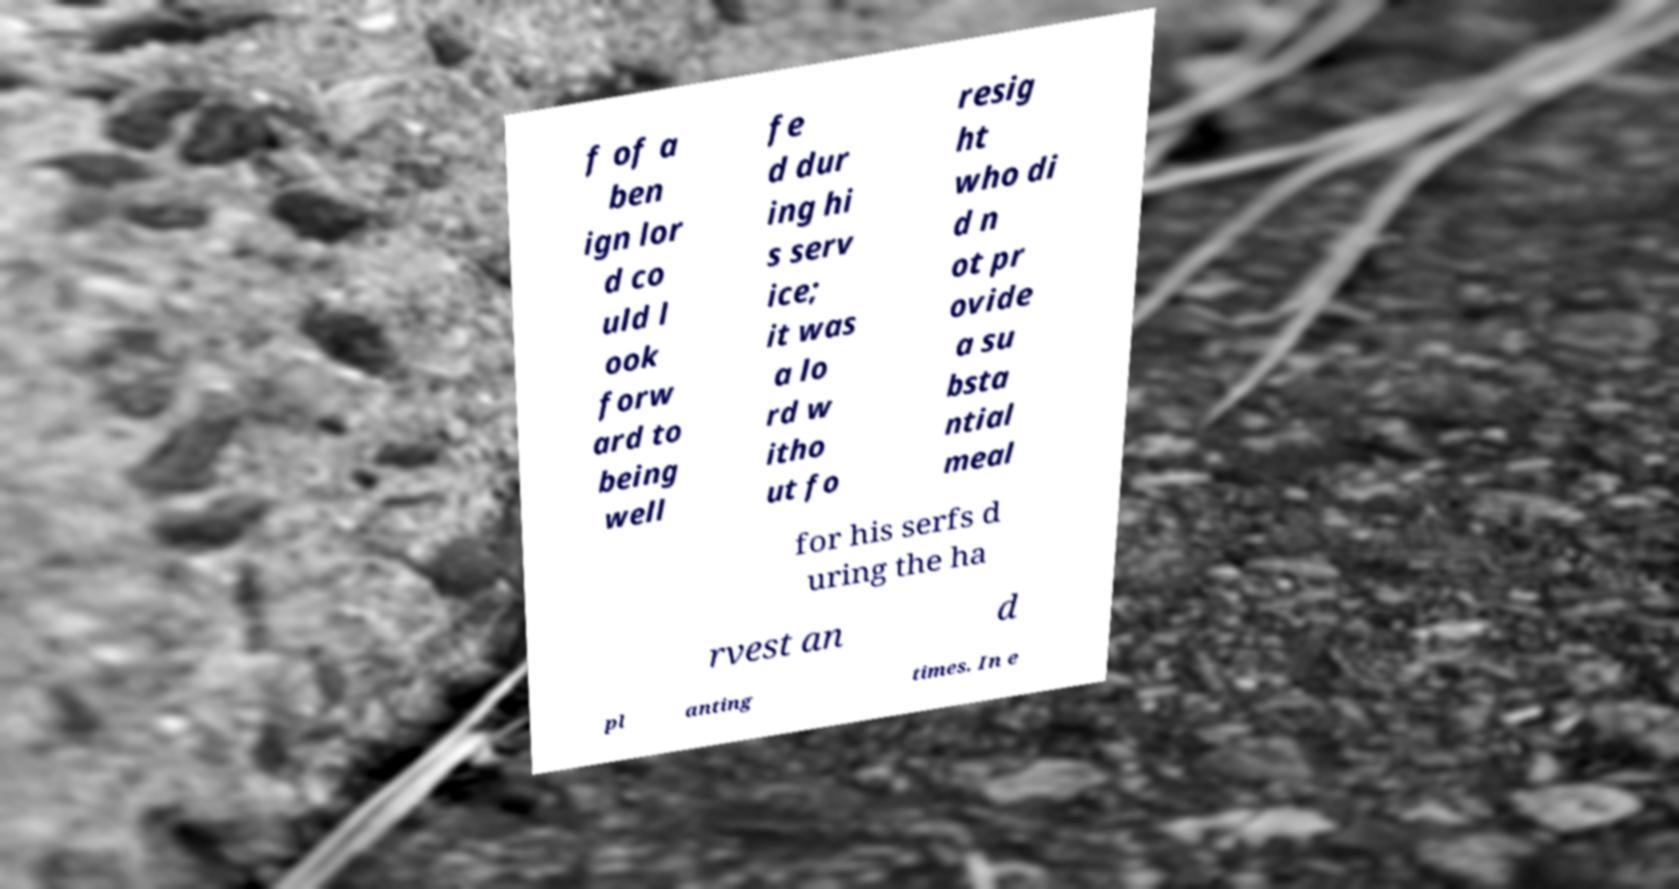What messages or text are displayed in this image? I need them in a readable, typed format. f of a ben ign lor d co uld l ook forw ard to being well fe d dur ing hi s serv ice; it was a lo rd w itho ut fo resig ht who di d n ot pr ovide a su bsta ntial meal for his serfs d uring the ha rvest an d pl anting times. In e 